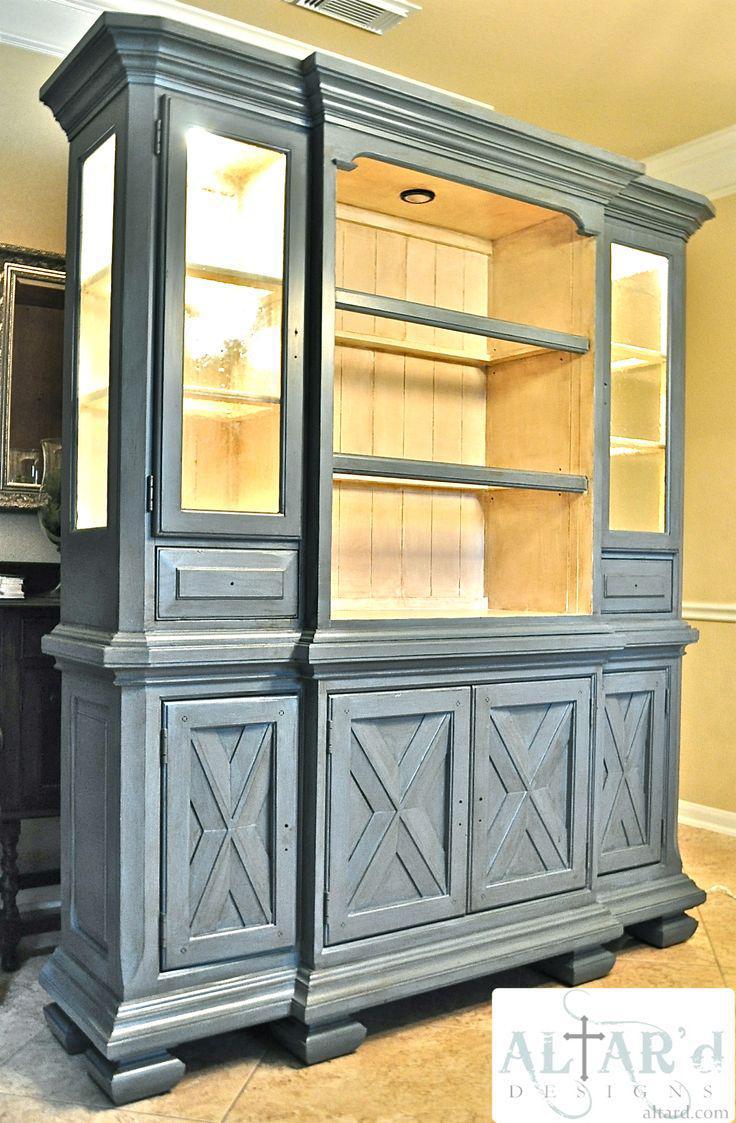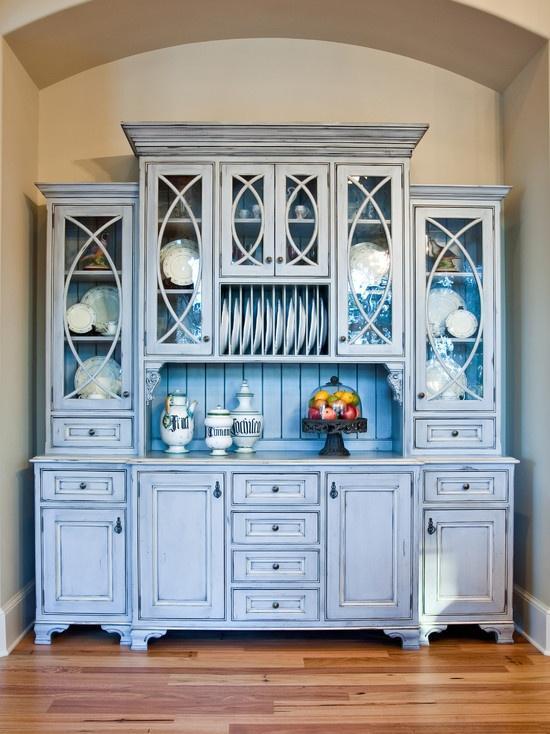The first image is the image on the left, the second image is the image on the right. Analyze the images presented: Is the assertion "There is a chair set up near a white cabinet." valid? Answer yes or no. No. The first image is the image on the left, the second image is the image on the right. Evaluate the accuracy of this statement regarding the images: "All of the cabinets pictured have flat tops instead of curved tops.". Is it true? Answer yes or no. Yes. 